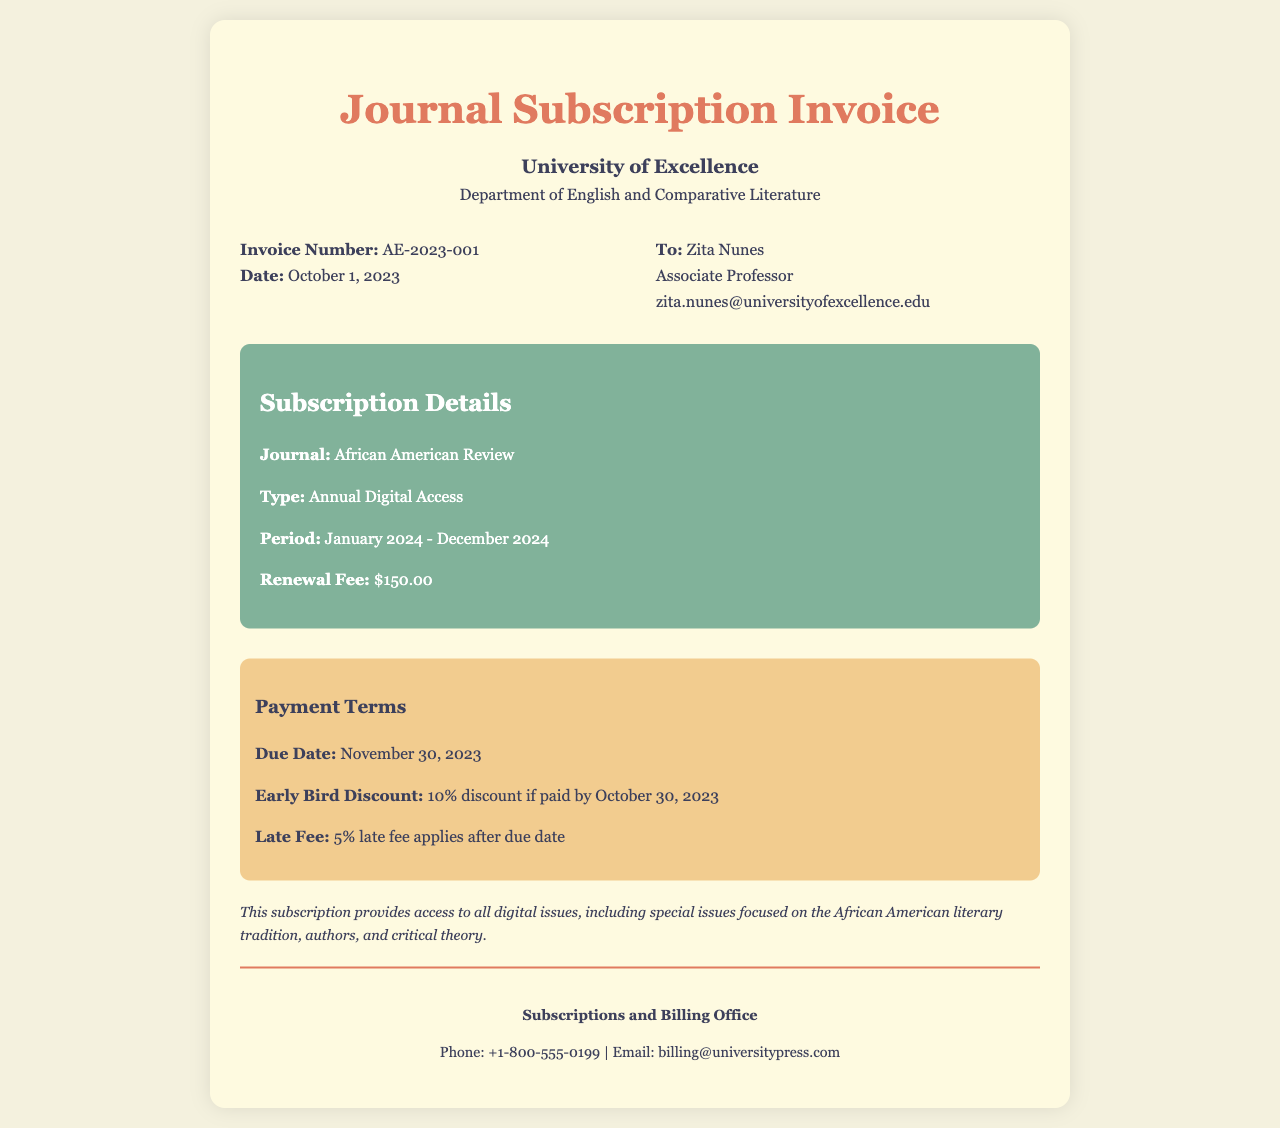What is the invoice number? The invoice number is a unique identifier for the billing document, which is AE-2023-001.
Answer: AE-2023-001 What is the total renewal fee for the subscription? The renewal fee for the subscription is listed in the document and is $150.00.
Answer: $150.00 What is the due date for the payment? The due date indicates when the payment must be made and is November 30, 2023.
Answer: November 30, 2023 What discount is available for early payment? The early bird discount provides a specific percentage off if payment is made by a certain date, which is 10% if paid by October 30, 2023.
Answer: 10% What type of access is included in the subscription? The subscription allows accessing digital content, specifically indicated as Annual Digital Access.
Answer: Annual Digital Access Who is the subscription addressed to? The recipient's name is specified in the invoice, which is Zita Nunes.
Answer: Zita Nunes What period does the subscription cover? The subscription period indicates the range of time the access is granted, which is January 2024 - December 2024.
Answer: January 2024 - December 2024 What is the late fee percentage after the due date? The late fee is a percentage charged if payment is delayed beyond the due date, set at 5%.
Answer: 5% 